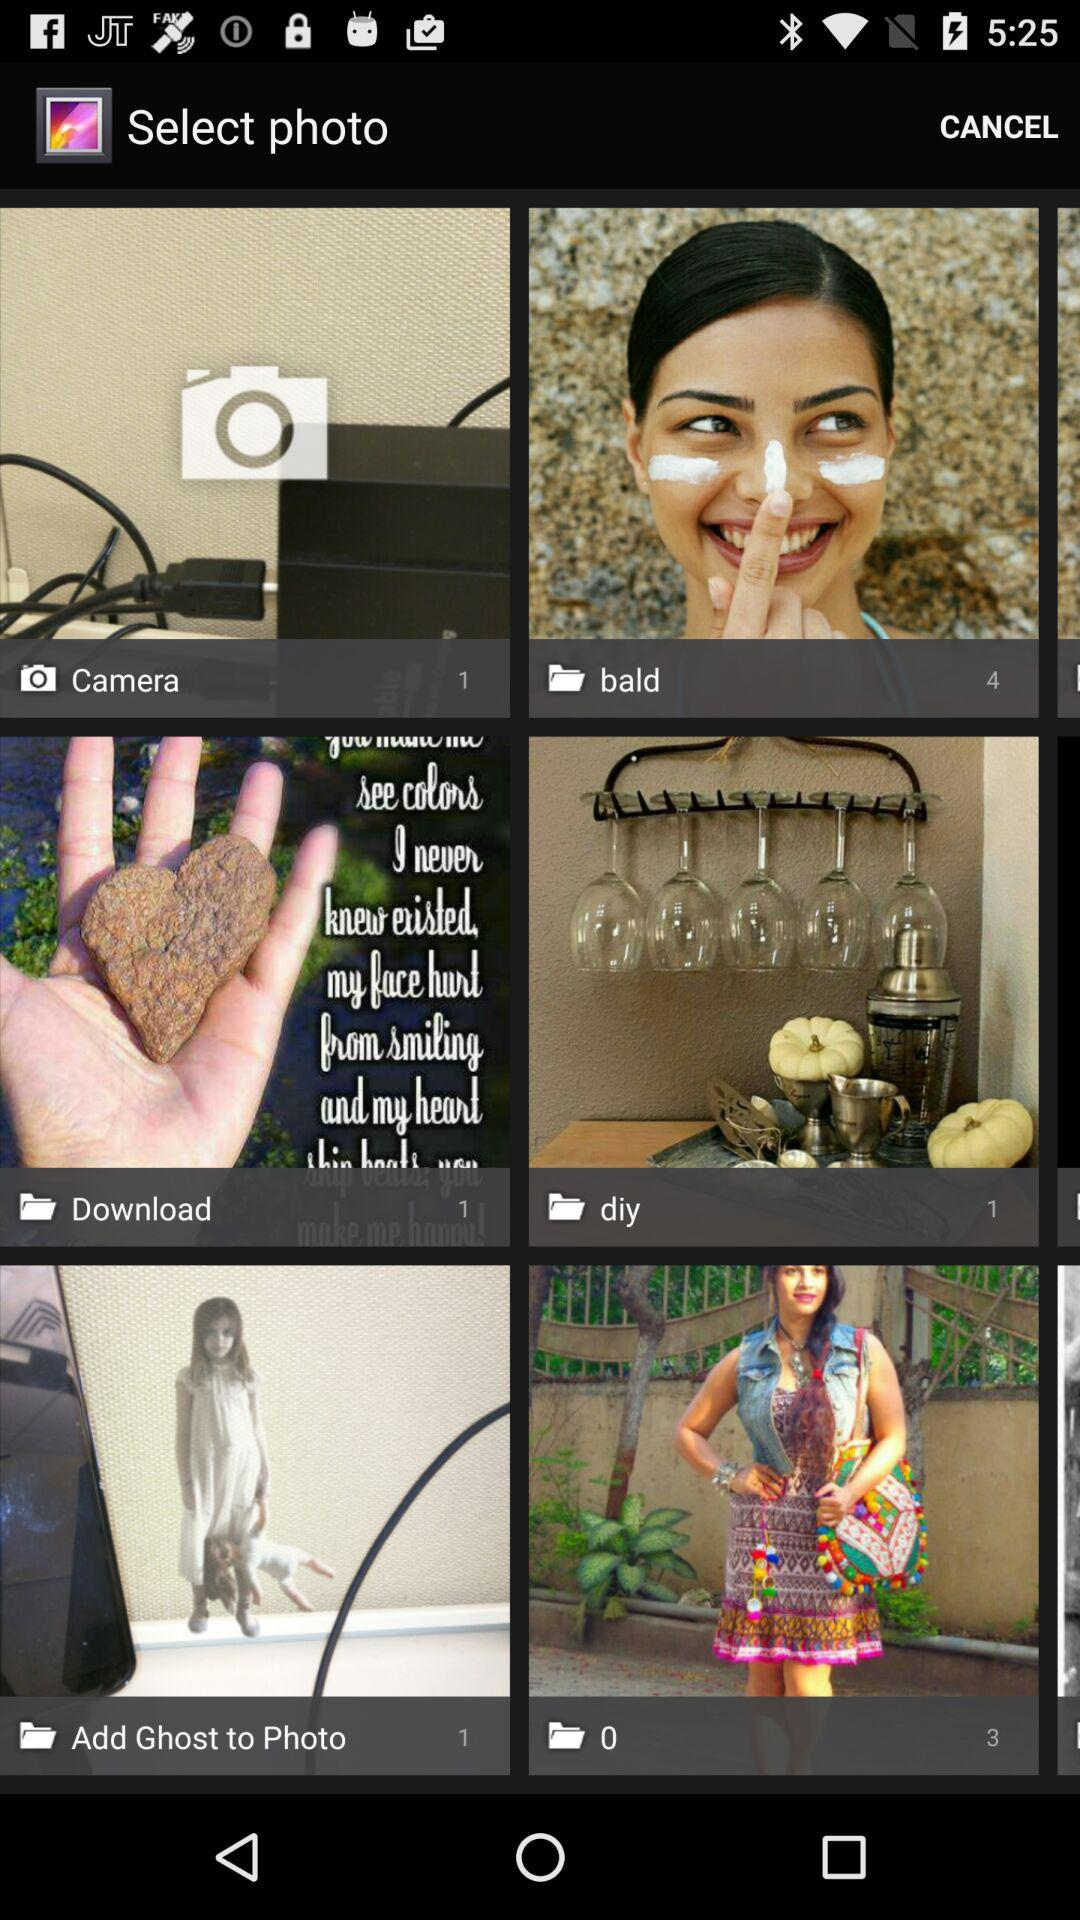What is the count of images in the "Add Ghost to Photo" folder? The count of images in the "Add Ghost to Photo" folder is 1. 